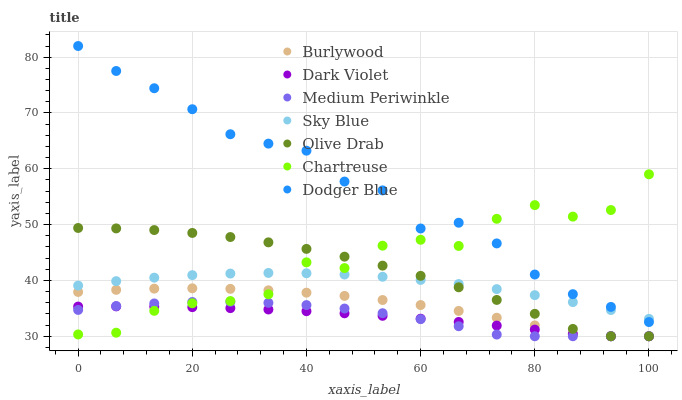Does Dark Violet have the minimum area under the curve?
Answer yes or no. Yes. Does Dodger Blue have the maximum area under the curve?
Answer yes or no. Yes. Does Medium Periwinkle have the minimum area under the curve?
Answer yes or no. No. Does Medium Periwinkle have the maximum area under the curve?
Answer yes or no. No. Is Dark Violet the smoothest?
Answer yes or no. Yes. Is Chartreuse the roughest?
Answer yes or no. Yes. Is Medium Periwinkle the smoothest?
Answer yes or no. No. Is Medium Periwinkle the roughest?
Answer yes or no. No. Does Burlywood have the lowest value?
Answer yes or no. Yes. Does Chartreuse have the lowest value?
Answer yes or no. No. Does Dodger Blue have the highest value?
Answer yes or no. Yes. Does Medium Periwinkle have the highest value?
Answer yes or no. No. Is Olive Drab less than Dodger Blue?
Answer yes or no. Yes. Is Dodger Blue greater than Olive Drab?
Answer yes or no. Yes. Does Dark Violet intersect Olive Drab?
Answer yes or no. Yes. Is Dark Violet less than Olive Drab?
Answer yes or no. No. Is Dark Violet greater than Olive Drab?
Answer yes or no. No. Does Olive Drab intersect Dodger Blue?
Answer yes or no. No. 